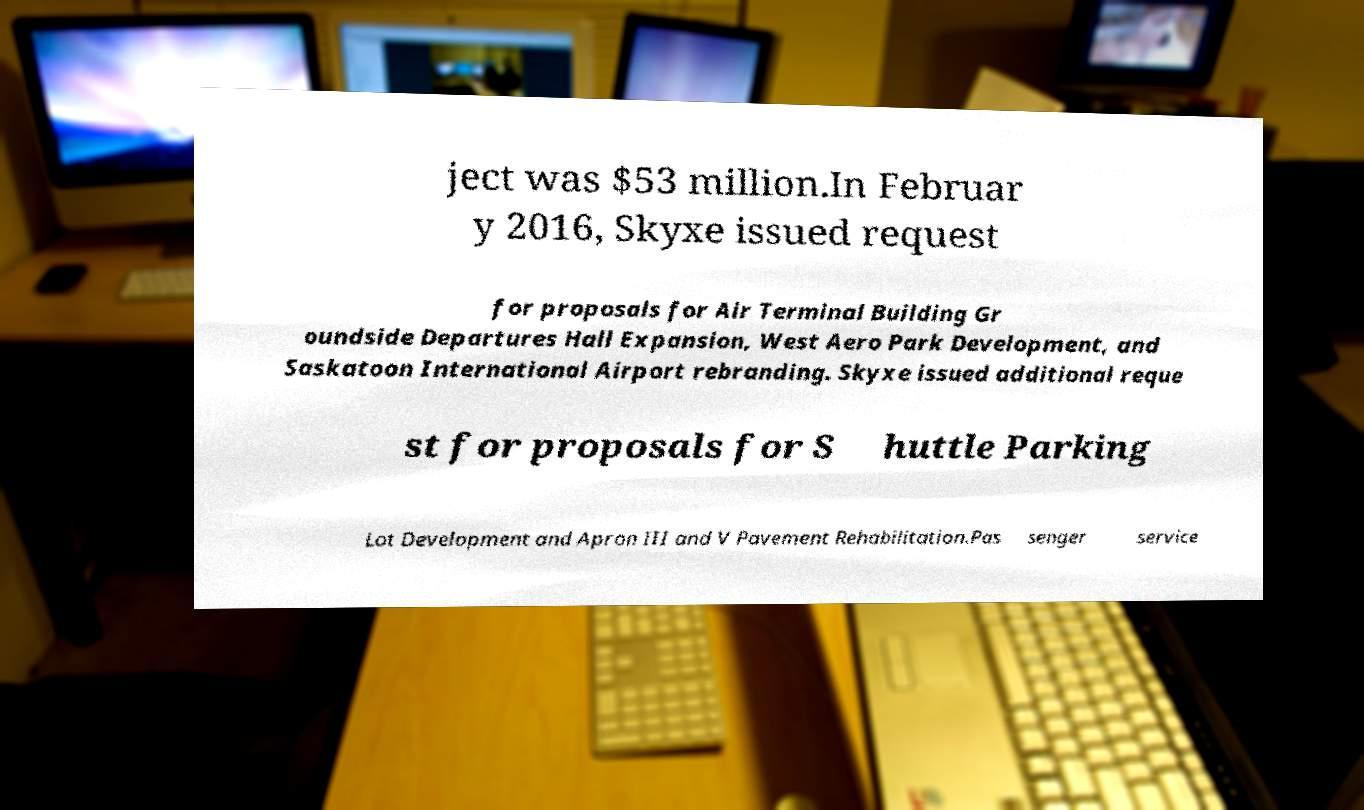Can you read and provide the text displayed in the image?This photo seems to have some interesting text. Can you extract and type it out for me? ject was $53 million.In Februar y 2016, Skyxe issued request for proposals for Air Terminal Building Gr oundside Departures Hall Expansion, West Aero Park Development, and Saskatoon International Airport rebranding. Skyxe issued additional reque st for proposals for S huttle Parking Lot Development and Apron III and V Pavement Rehabilitation.Pas senger service 